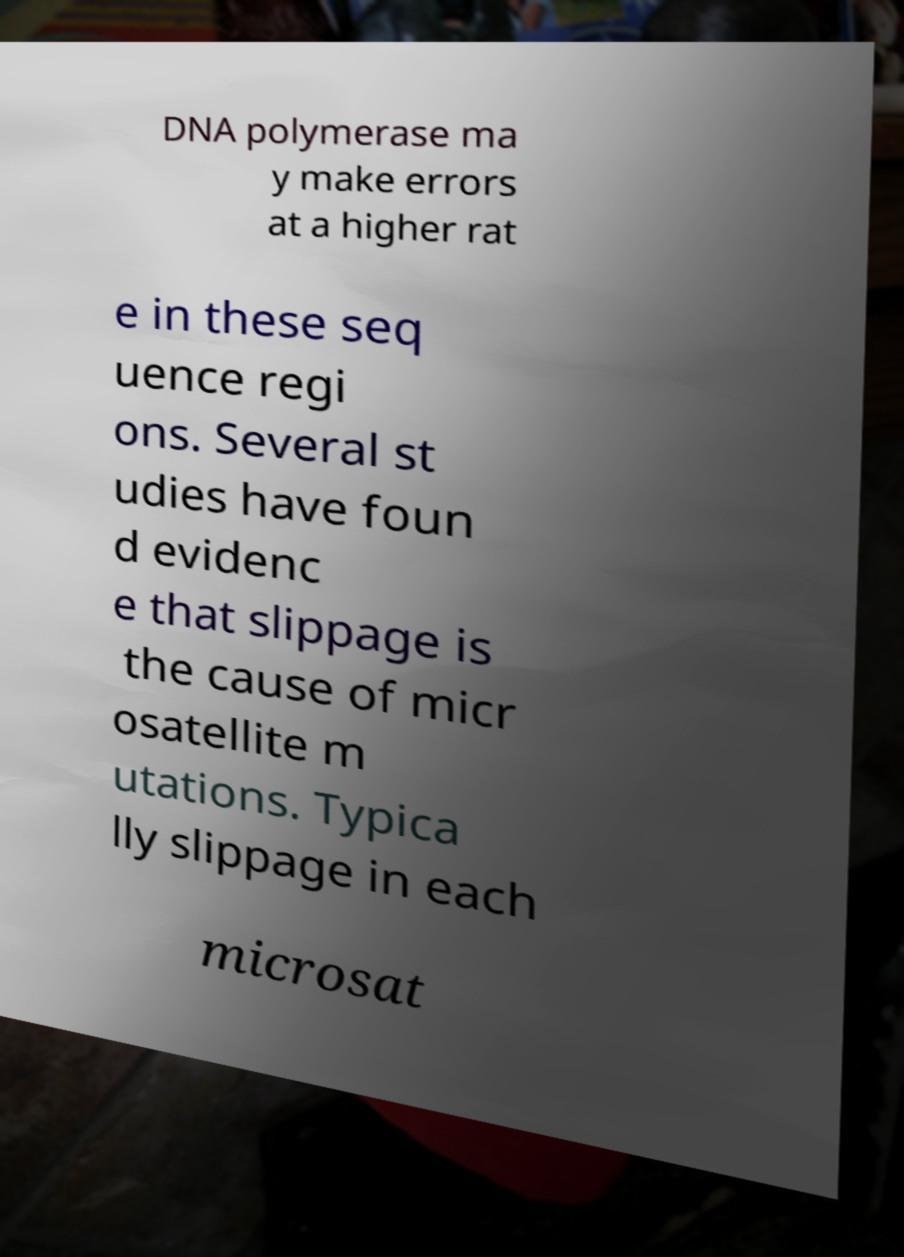Can you read and provide the text displayed in the image?This photo seems to have some interesting text. Can you extract and type it out for me? DNA polymerase ma y make errors at a higher rat e in these seq uence regi ons. Several st udies have foun d evidenc e that slippage is the cause of micr osatellite m utations. Typica lly slippage in each microsat 